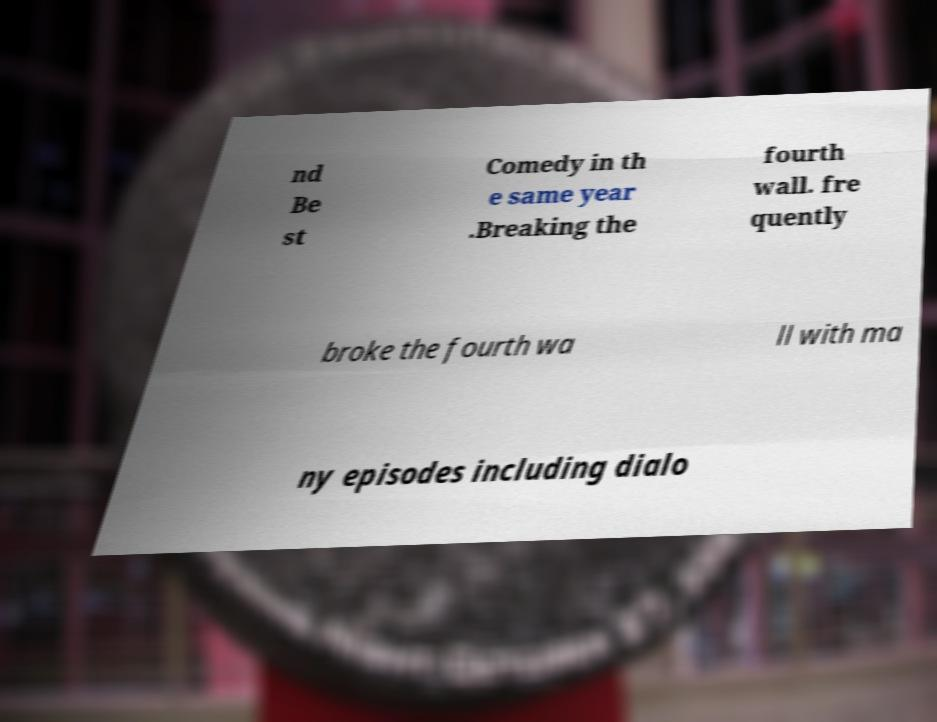There's text embedded in this image that I need extracted. Can you transcribe it verbatim? nd Be st Comedy in th e same year .Breaking the fourth wall. fre quently broke the fourth wa ll with ma ny episodes including dialo 